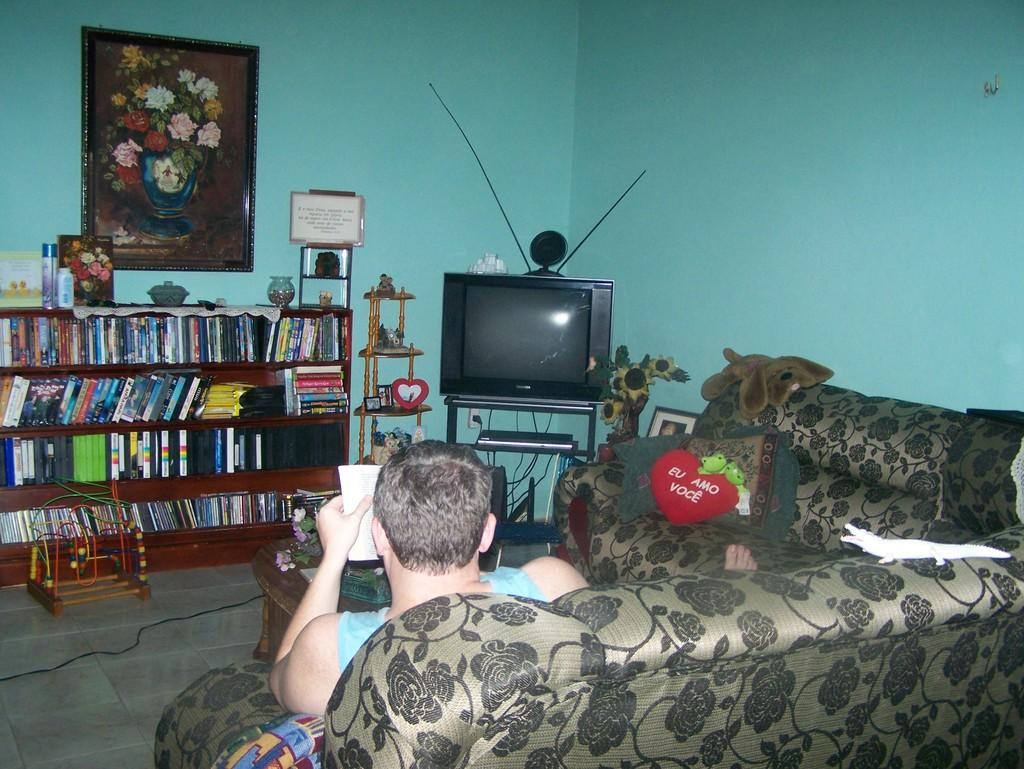What type of furniture is present in the image? There is a sofa set in the image. Who or what is on the sofa set? A person is seated on the sofa set. What is located in front of the sofa set? There is a book shelf in front of the sofa set. What is hanging on the wall in the image? There is a photo frame on the wall. What type of electronic device is present in the image? There is a television in the image. What type of accessory is present on the sofa set? There is a pillow in the image. What type of religious prose is written on the wall in the image? There is no religious prose or any writing present on the wall in the image. The image only features a photo frame on the wall. 